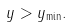Convert formula to latex. <formula><loc_0><loc_0><loc_500><loc_500>y > y _ { \min } .</formula> 